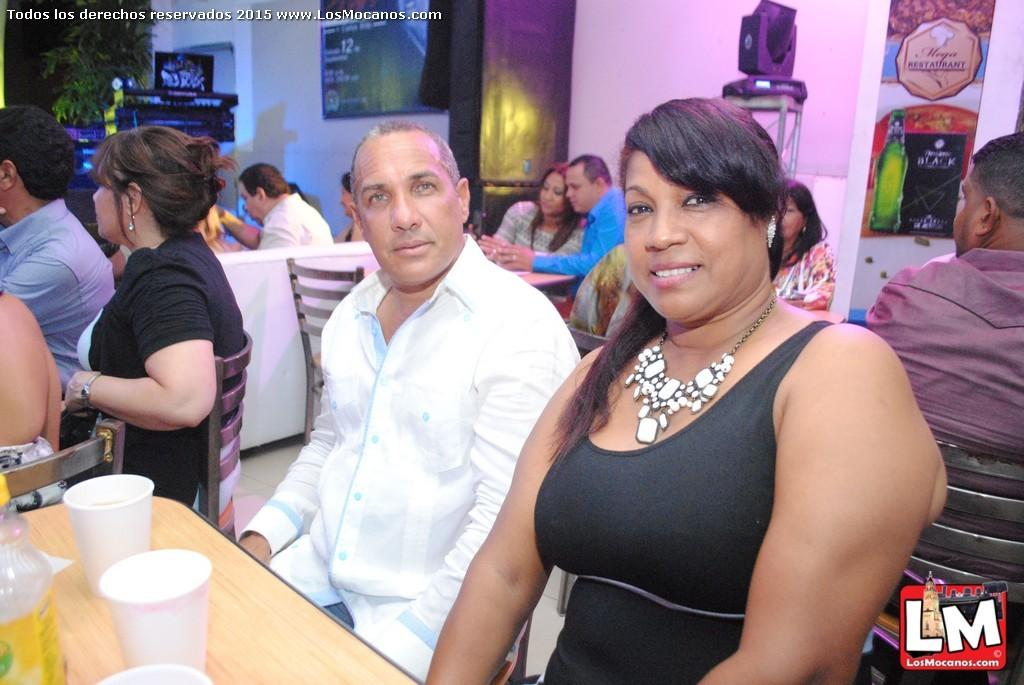What are the people in the image doing? The persons in the image are sitting on chairs. Where is the table located in the image? The table is located at the bottom left corner of the image. What items can be seen on the table? There are glasses and a bottle on the table. What type of harmony is being played by the persons in the image? There is no indication of music or harmony in the image; the persons are simply sitting on chairs. 